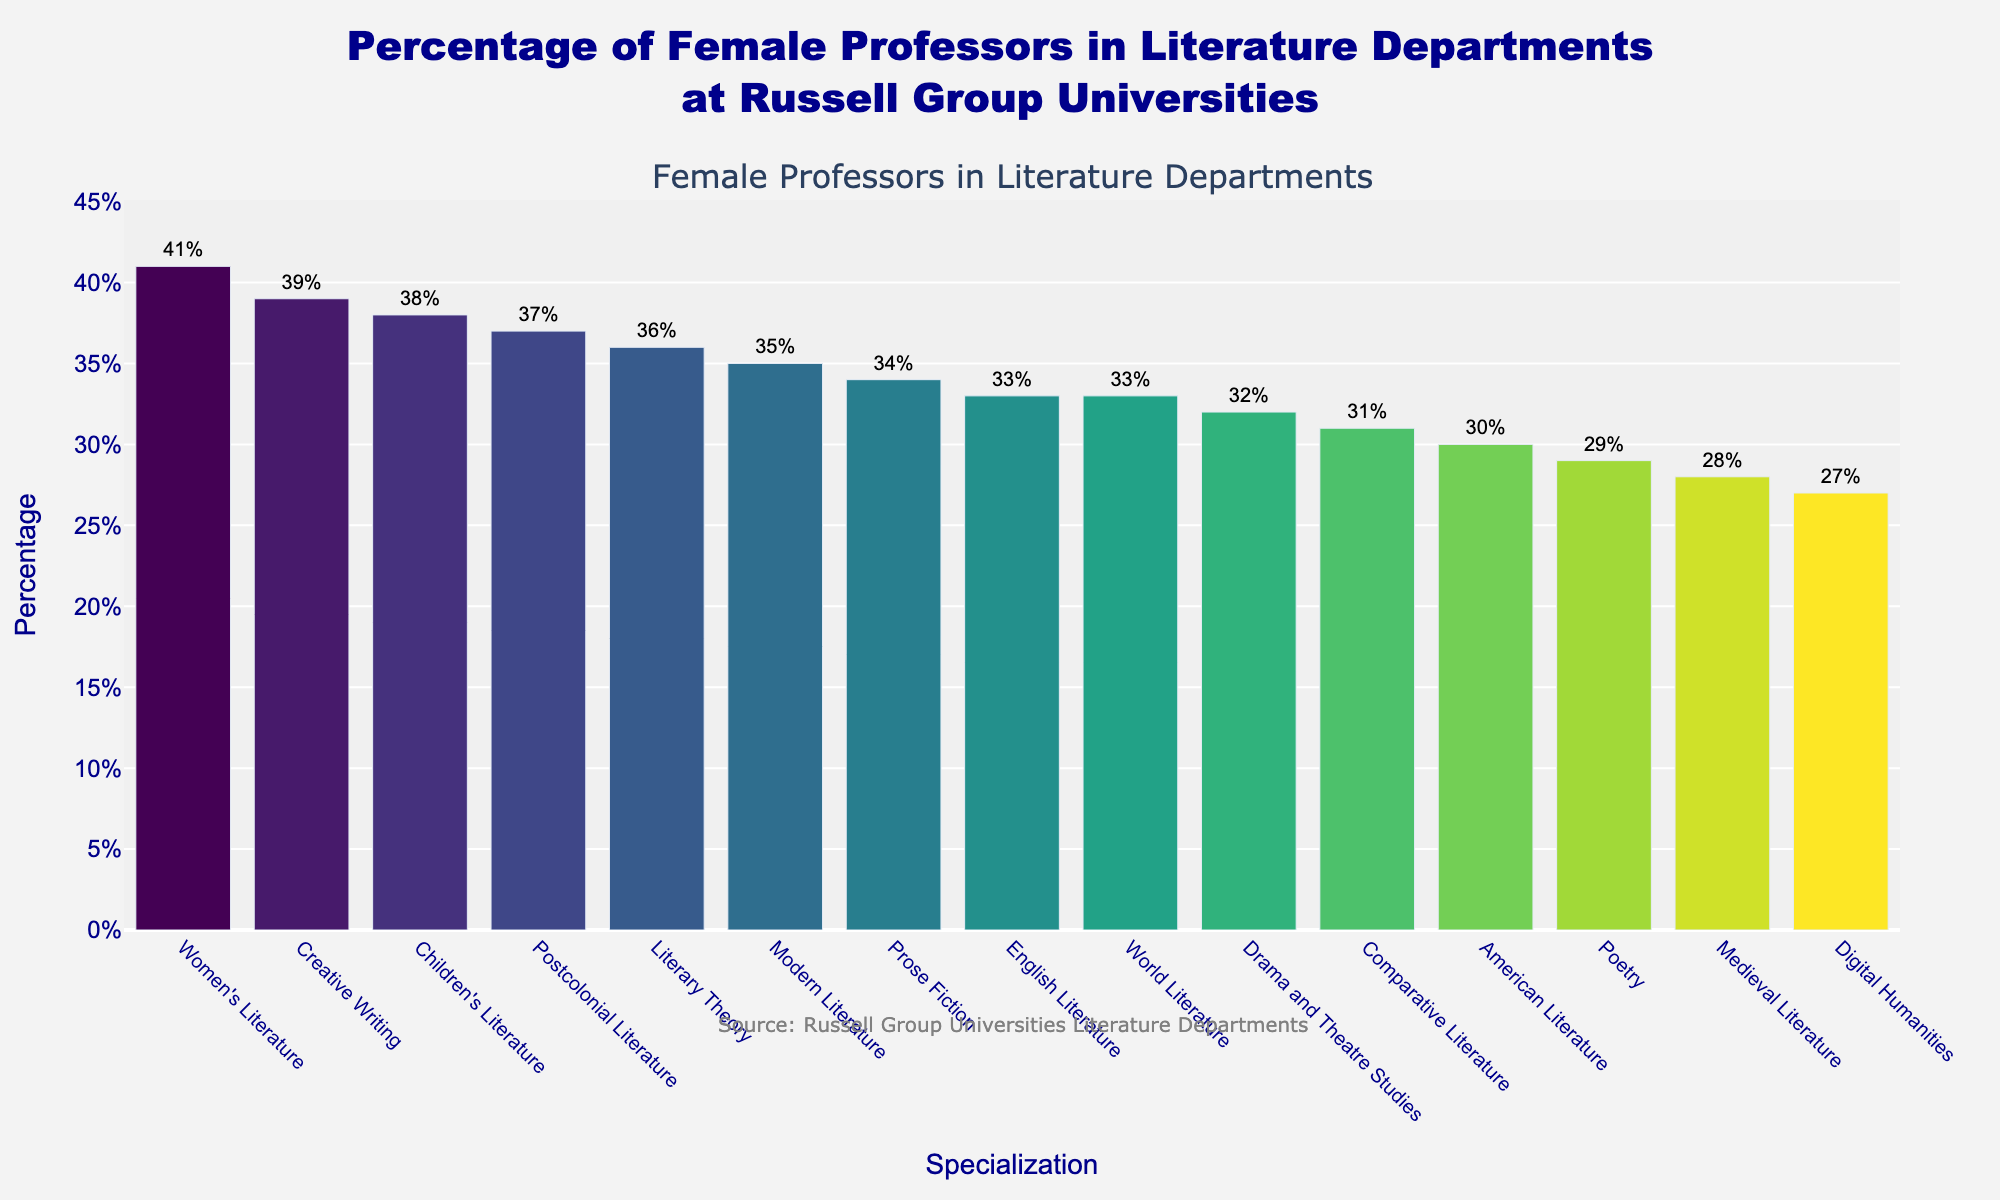What is the percentage of female professors in Women's Literature? The figure shows different specializations and their corresponding percentages of female professors. Locate "Women's Literature" on the x-axis and read the corresponding value on the y-axis.
Answer: 41% Which specialization has the lowest percentage of female professors? Identify the bar with the shortest height and read the corresponding specialization name from the x-axis.
Answer: Digital Humanities What is the difference in the percentage of female professors between Postcolonial Literature and American Literature? Locate the bars for "Postcolonial Literature" and "American Literature" on the x-axis. Note their percentages (37% and 30%, respectively) and calculate the difference: 37% - 30% = 7%.
Answer: 7% How many specializations have a percentage of female professors greater than 35%? Count the number of bars that have a y-axis value greater than 35%.
Answer: 5 Which specializations have a percentage of female professors equal to 33%? Locate the bars with a y-value of 33% and read their corresponding specialization names from the x-axis.
Answer: English Literature, World Literature What is the average percentage of female professors in all the specializations? Sum the percentages of all specializations and divide by the number of specializations: (28 + 35 + 31 + 33 + 30 + 37 + 32 + 29 + 34 + 36 + 41 + 38 + 33 + 27 + 39) / 15 ≈ 33.67.
Answer: 33.67% Is the percentage of female professors higher in Poetry or Prose Fiction? Compare the y-axis values of "Poetry" and "Prose Fiction". Note that Poetry has 29% and Prose Fiction has 34%. Since 34% is higher than 29%, Prose Fiction has a higher percentage.
Answer: Prose Fiction What is the median percentage of female professors across all specializations? Sort the percentages and find the middle value in the sorted list. The sorted list is (27, 28, 29, 30, 31, 32, 33, 33, 34, 35, 36, 37, 38, 39, 41), and the middle value is 33.
Answer: 33 Which specializations show a percentage of female professors closest to the average percentage? The average percentage is approximately 33.67%. Locate the specializations with percentages closest to 33.67%, which are "English Literature" and "World Literature" both with 33%.
Answer: English Literature, World Literature What is the combined percentage of female professors in Medieval Literature and Digital Humanities? Locate the percentages for "Medieval Literature" and "Digital Humanities" (28% and 27% respectively) and sum them: 28% + 27% = 55%.
Answer: 55% 